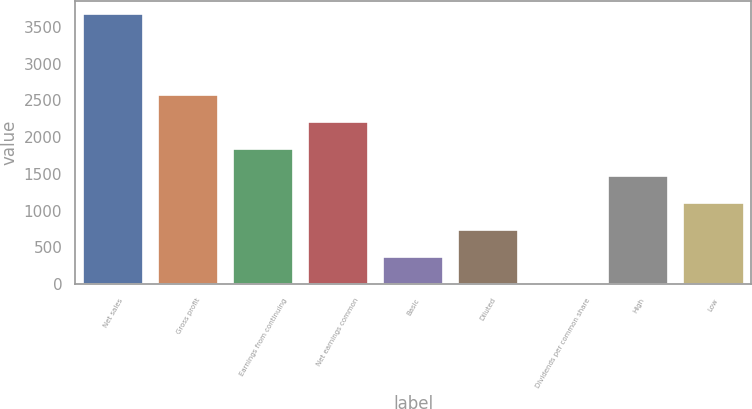<chart> <loc_0><loc_0><loc_500><loc_500><bar_chart><fcel>Net sales<fcel>Gross profit<fcel>Earnings from continuing<fcel>Net earnings common<fcel>Basic<fcel>Diluted<fcel>Dividends per common share<fcel>High<fcel>Low<nl><fcel>3674<fcel>2571.92<fcel>1837.22<fcel>2204.57<fcel>367.82<fcel>735.17<fcel>0.47<fcel>1469.87<fcel>1102.52<nl></chart> 